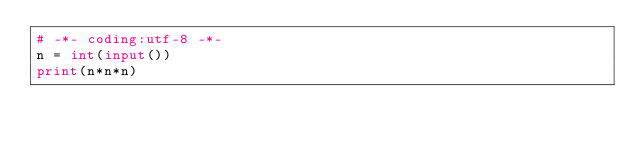<code> <loc_0><loc_0><loc_500><loc_500><_Python_># -*- coding:utf-8 -*-
n = int(input())
print(n*n*n)</code> 